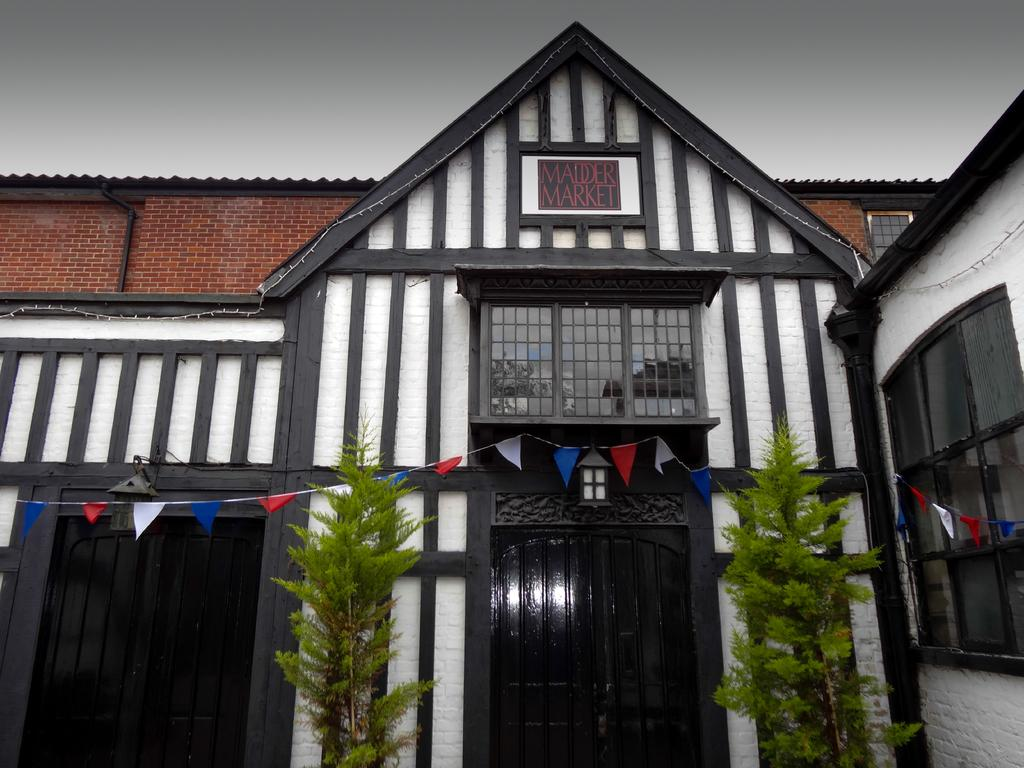What type of structure is visible in the image? There is a building in the image. What feature can be seen on the building's exterior? The building has glass windows. How can people enter or exit the building? The building has doors. What decorative elements are present in front of the building? There are flags and plants in front of the building. What type of hate can be seen on the faces of the people in the image? There are no people visible in the image, so it is not possible to determine their emotions or expressions. 